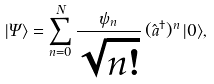Convert formula to latex. <formula><loc_0><loc_0><loc_500><loc_500>| \Psi \rangle = \sum _ { n = 0 } ^ { N } \frac { \psi _ { n } } { \sqrt { n ! } } \, ( \hat { a } ^ { \dagger } ) ^ { n } \, | 0 \rangle ,</formula> 